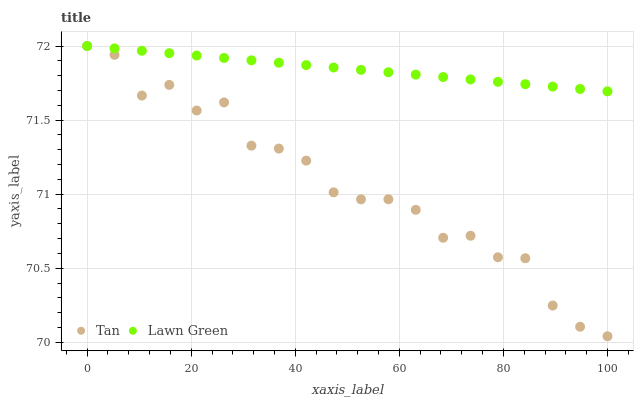Does Tan have the minimum area under the curve?
Answer yes or no. Yes. Does Lawn Green have the maximum area under the curve?
Answer yes or no. Yes. Does Tan have the maximum area under the curve?
Answer yes or no. No. Is Lawn Green the smoothest?
Answer yes or no. Yes. Is Tan the roughest?
Answer yes or no. Yes. Is Tan the smoothest?
Answer yes or no. No. Does Tan have the lowest value?
Answer yes or no. Yes. Does Tan have the highest value?
Answer yes or no. Yes. Does Lawn Green intersect Tan?
Answer yes or no. Yes. Is Lawn Green less than Tan?
Answer yes or no. No. Is Lawn Green greater than Tan?
Answer yes or no. No. 